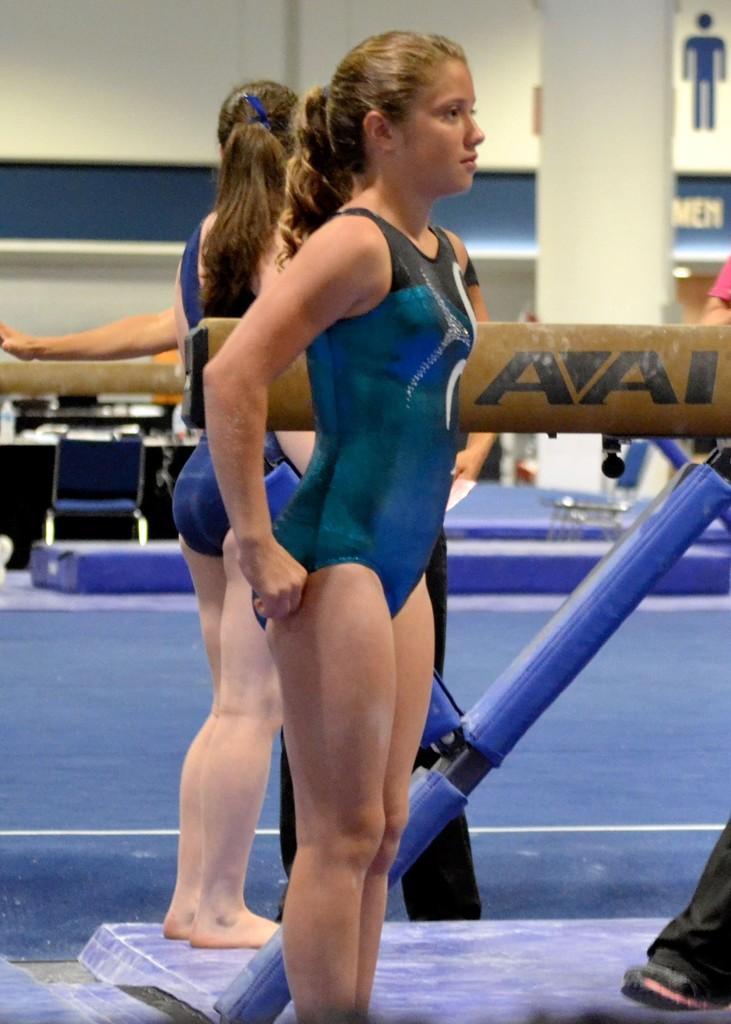Who or what can be seen in the image? There are people in the image. Can you describe the object with blue and brown colors in the image? There is an object with blue and brown colors in the image, but its specific nature is not mentioned in the facts. What architectural feature is visible in the background of the image? There is a pillar in the background of the image. What can be found on the wall in the background of the image? There are boards on the wall in the background of the image. What comfort does the club provide to the people in the image? There is no mention of a club in the image or the facts provided. 